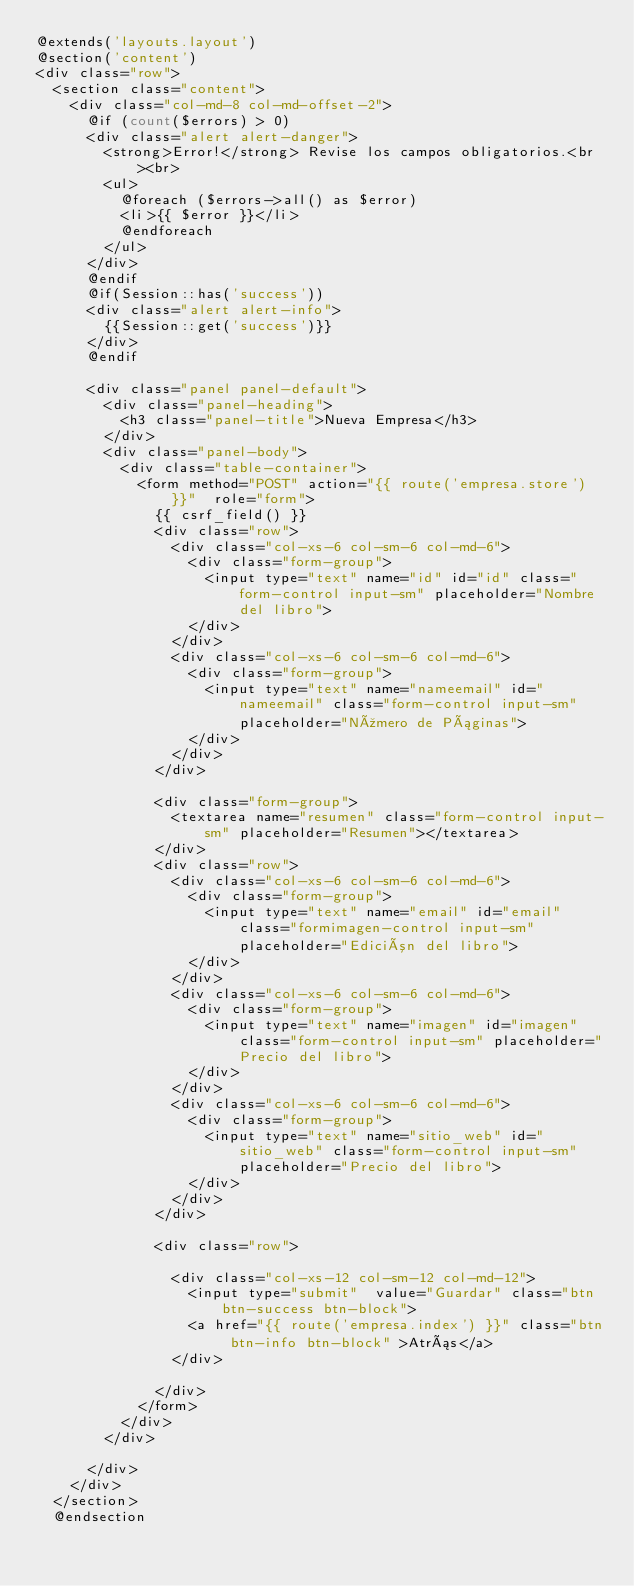<code> <loc_0><loc_0><loc_500><loc_500><_PHP_>@extends('layouts.layout')
@section('content')
<div class="row">
	<section class="content">
		<div class="col-md-8 col-md-offset-2">
			@if (count($errors) > 0)
			<div class="alert alert-danger">
				<strong>Error!</strong> Revise los campos obligatorios.<br><br>
				<ul>
					@foreach ($errors->all() as $error)
					<li>{{ $error }}</li>
					@endforeach
				</ul>
			</div>
			@endif
			@if(Session::has('success'))
			<div class="alert alert-info">
				{{Session::get('success')}}
			</div>
			@endif

			<div class="panel panel-default">
				<div class="panel-heading">
					<h3 class="panel-title">Nueva Empresa</h3>
				</div>
				<div class="panel-body">					
					<div class="table-container">
						<form method="POST" action="{{ route('empresa.store') }}"  role="form">
							{{ csrf_field() }}
							<div class="row">
								<div class="col-xs-6 col-sm-6 col-md-6">
									<div class="form-group">
										<input type="text" name="id" id="id" class="form-control input-sm" placeholder="Nombre del libro">
									</div>
								</div>
								<div class="col-xs-6 col-sm-6 col-md-6">
									<div class="form-group">
										<input type="text" name="nameemail" id="nameemail" class="form-control input-sm" placeholder="Número de Páginas">
									</div>
								</div>
							</div>

							<div class="form-group">
								<textarea name="resumen" class="form-control input-sm" placeholder="Resumen"></textarea>
							</div>
							<div class="row">
								<div class="col-xs-6 col-sm-6 col-md-6">
									<div class="form-group">
										<input type="text" name="email" id="email" class="formimagen-control input-sm" placeholder="Edición del libro">
									</div>
								</div>
								<div class="col-xs-6 col-sm-6 col-md-6">
									<div class="form-group">
										<input type="text" name="imagen" id="imagen" class="form-control input-sm" placeholder="Precio del libro">
									</div>
								</div>
								<div class="col-xs-6 col-sm-6 col-md-6">
									<div class="form-group">
										<input type="text" name="sitio_web" id="sitio_web" class="form-control input-sm" placeholder="Precio del libro">
									</div>
								</div>
							</div>
							
							<div class="row">

								<div class="col-xs-12 col-sm-12 col-md-12">
									<input type="submit"  value="Guardar" class="btn btn-success btn-block">
									<a href="{{ route('empresa.index') }}" class="btn btn-info btn-block" >Atrás</a>
								</div>	

							</div>
						</form>
					</div>
				</div>

			</div>
		</div>
	</section>
	@endsection</code> 